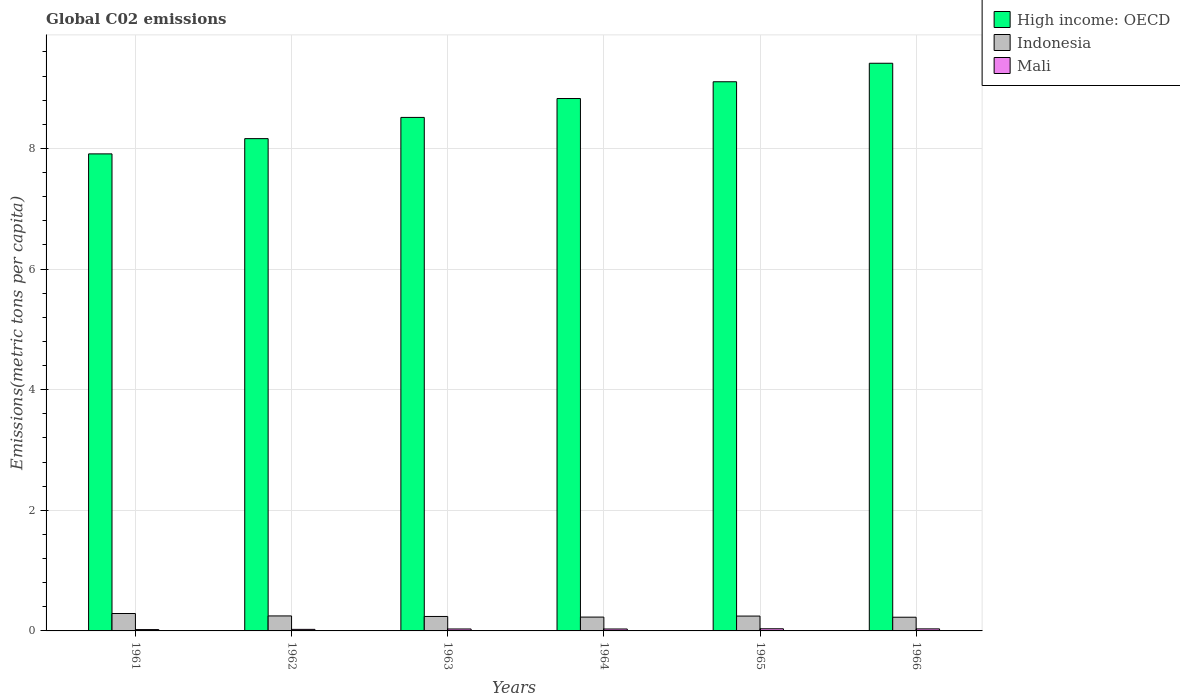How many different coloured bars are there?
Ensure brevity in your answer.  3. Are the number of bars on each tick of the X-axis equal?
Offer a very short reply. Yes. What is the label of the 2nd group of bars from the left?
Give a very brief answer. 1962. In how many cases, is the number of bars for a given year not equal to the number of legend labels?
Ensure brevity in your answer.  0. What is the amount of CO2 emitted in in High income: OECD in 1962?
Your answer should be compact. 8.16. Across all years, what is the maximum amount of CO2 emitted in in High income: OECD?
Your answer should be compact. 9.41. Across all years, what is the minimum amount of CO2 emitted in in High income: OECD?
Your response must be concise. 7.91. In which year was the amount of CO2 emitted in in High income: OECD maximum?
Offer a terse response. 1966. In which year was the amount of CO2 emitted in in Mali minimum?
Keep it short and to the point. 1961. What is the total amount of CO2 emitted in in Mali in the graph?
Ensure brevity in your answer.  0.18. What is the difference between the amount of CO2 emitted in in High income: OECD in 1962 and that in 1963?
Your answer should be very brief. -0.35. What is the difference between the amount of CO2 emitted in in Mali in 1962 and the amount of CO2 emitted in in Indonesia in 1961?
Offer a terse response. -0.26. What is the average amount of CO2 emitted in in Indonesia per year?
Give a very brief answer. 0.25. In the year 1962, what is the difference between the amount of CO2 emitted in in High income: OECD and amount of CO2 emitted in in Indonesia?
Ensure brevity in your answer.  7.91. In how many years, is the amount of CO2 emitted in in High income: OECD greater than 6.8 metric tons per capita?
Your response must be concise. 6. What is the ratio of the amount of CO2 emitted in in Mali in 1963 to that in 1965?
Provide a succinct answer. 0.91. Is the amount of CO2 emitted in in Mali in 1964 less than that in 1965?
Ensure brevity in your answer.  Yes. Is the difference between the amount of CO2 emitted in in High income: OECD in 1963 and 1966 greater than the difference between the amount of CO2 emitted in in Indonesia in 1963 and 1966?
Your answer should be very brief. No. What is the difference between the highest and the second highest amount of CO2 emitted in in High income: OECD?
Your answer should be very brief. 0.31. What is the difference between the highest and the lowest amount of CO2 emitted in in Indonesia?
Give a very brief answer. 0.06. In how many years, is the amount of CO2 emitted in in Mali greater than the average amount of CO2 emitted in in Mali taken over all years?
Make the answer very short. 4. What does the 3rd bar from the left in 1962 represents?
Your response must be concise. Mali. What does the 2nd bar from the right in 1966 represents?
Offer a very short reply. Indonesia. Is it the case that in every year, the sum of the amount of CO2 emitted in in High income: OECD and amount of CO2 emitted in in Mali is greater than the amount of CO2 emitted in in Indonesia?
Keep it short and to the point. Yes. How many bars are there?
Offer a very short reply. 18. Are all the bars in the graph horizontal?
Provide a succinct answer. No. Are the values on the major ticks of Y-axis written in scientific E-notation?
Make the answer very short. No. Does the graph contain grids?
Make the answer very short. Yes. How are the legend labels stacked?
Give a very brief answer. Vertical. What is the title of the graph?
Provide a succinct answer. Global C02 emissions. What is the label or title of the Y-axis?
Your response must be concise. Emissions(metric tons per capita). What is the Emissions(metric tons per capita) of High income: OECD in 1961?
Your answer should be compact. 7.91. What is the Emissions(metric tons per capita) in Indonesia in 1961?
Give a very brief answer. 0.29. What is the Emissions(metric tons per capita) of Mali in 1961?
Your answer should be compact. 0.02. What is the Emissions(metric tons per capita) of High income: OECD in 1962?
Offer a terse response. 8.16. What is the Emissions(metric tons per capita) in Indonesia in 1962?
Ensure brevity in your answer.  0.25. What is the Emissions(metric tons per capita) in Mali in 1962?
Keep it short and to the point. 0.03. What is the Emissions(metric tons per capita) in High income: OECD in 1963?
Ensure brevity in your answer.  8.51. What is the Emissions(metric tons per capita) of Indonesia in 1963?
Your answer should be compact. 0.24. What is the Emissions(metric tons per capita) of Mali in 1963?
Offer a terse response. 0.03. What is the Emissions(metric tons per capita) of High income: OECD in 1964?
Your answer should be compact. 8.83. What is the Emissions(metric tons per capita) of Indonesia in 1964?
Provide a succinct answer. 0.23. What is the Emissions(metric tons per capita) of Mali in 1964?
Your response must be concise. 0.03. What is the Emissions(metric tons per capita) of High income: OECD in 1965?
Your answer should be very brief. 9.11. What is the Emissions(metric tons per capita) in Indonesia in 1965?
Your response must be concise. 0.25. What is the Emissions(metric tons per capita) of Mali in 1965?
Provide a short and direct response. 0.04. What is the Emissions(metric tons per capita) in High income: OECD in 1966?
Offer a very short reply. 9.41. What is the Emissions(metric tons per capita) in Indonesia in 1966?
Offer a very short reply. 0.23. What is the Emissions(metric tons per capita) of Mali in 1966?
Your response must be concise. 0.03. Across all years, what is the maximum Emissions(metric tons per capita) of High income: OECD?
Your answer should be very brief. 9.41. Across all years, what is the maximum Emissions(metric tons per capita) of Indonesia?
Your response must be concise. 0.29. Across all years, what is the maximum Emissions(metric tons per capita) in Mali?
Provide a short and direct response. 0.04. Across all years, what is the minimum Emissions(metric tons per capita) of High income: OECD?
Your response must be concise. 7.91. Across all years, what is the minimum Emissions(metric tons per capita) in Indonesia?
Make the answer very short. 0.23. Across all years, what is the minimum Emissions(metric tons per capita) in Mali?
Provide a short and direct response. 0.02. What is the total Emissions(metric tons per capita) in High income: OECD in the graph?
Your answer should be very brief. 51.93. What is the total Emissions(metric tons per capita) in Indonesia in the graph?
Make the answer very short. 1.48. What is the total Emissions(metric tons per capita) in Mali in the graph?
Provide a succinct answer. 0.18. What is the difference between the Emissions(metric tons per capita) in High income: OECD in 1961 and that in 1962?
Your response must be concise. -0.25. What is the difference between the Emissions(metric tons per capita) of Indonesia in 1961 and that in 1962?
Your response must be concise. 0.04. What is the difference between the Emissions(metric tons per capita) in Mali in 1961 and that in 1962?
Keep it short and to the point. -0. What is the difference between the Emissions(metric tons per capita) in High income: OECD in 1961 and that in 1963?
Offer a very short reply. -0.6. What is the difference between the Emissions(metric tons per capita) in Indonesia in 1961 and that in 1963?
Your answer should be very brief. 0.05. What is the difference between the Emissions(metric tons per capita) in Mali in 1961 and that in 1963?
Your answer should be very brief. -0.01. What is the difference between the Emissions(metric tons per capita) of High income: OECD in 1961 and that in 1964?
Your answer should be compact. -0.92. What is the difference between the Emissions(metric tons per capita) of Indonesia in 1961 and that in 1964?
Your answer should be very brief. 0.06. What is the difference between the Emissions(metric tons per capita) of Mali in 1961 and that in 1964?
Ensure brevity in your answer.  -0.01. What is the difference between the Emissions(metric tons per capita) of High income: OECD in 1961 and that in 1965?
Make the answer very short. -1.2. What is the difference between the Emissions(metric tons per capita) of Indonesia in 1961 and that in 1965?
Provide a succinct answer. 0.04. What is the difference between the Emissions(metric tons per capita) in Mali in 1961 and that in 1965?
Give a very brief answer. -0.01. What is the difference between the Emissions(metric tons per capita) in High income: OECD in 1961 and that in 1966?
Give a very brief answer. -1.5. What is the difference between the Emissions(metric tons per capita) in Indonesia in 1961 and that in 1966?
Your answer should be compact. 0.06. What is the difference between the Emissions(metric tons per capita) in Mali in 1961 and that in 1966?
Provide a succinct answer. -0.01. What is the difference between the Emissions(metric tons per capita) in High income: OECD in 1962 and that in 1963?
Offer a terse response. -0.35. What is the difference between the Emissions(metric tons per capita) in Indonesia in 1962 and that in 1963?
Your answer should be compact. 0.01. What is the difference between the Emissions(metric tons per capita) of Mali in 1962 and that in 1963?
Keep it short and to the point. -0.01. What is the difference between the Emissions(metric tons per capita) of High income: OECD in 1962 and that in 1964?
Provide a short and direct response. -0.66. What is the difference between the Emissions(metric tons per capita) in Indonesia in 1962 and that in 1964?
Ensure brevity in your answer.  0.02. What is the difference between the Emissions(metric tons per capita) of Mali in 1962 and that in 1964?
Ensure brevity in your answer.  -0.01. What is the difference between the Emissions(metric tons per capita) of High income: OECD in 1962 and that in 1965?
Ensure brevity in your answer.  -0.94. What is the difference between the Emissions(metric tons per capita) in Indonesia in 1962 and that in 1965?
Your response must be concise. 0. What is the difference between the Emissions(metric tons per capita) of Mali in 1962 and that in 1965?
Your answer should be very brief. -0.01. What is the difference between the Emissions(metric tons per capita) of High income: OECD in 1962 and that in 1966?
Provide a succinct answer. -1.25. What is the difference between the Emissions(metric tons per capita) in Indonesia in 1962 and that in 1966?
Offer a very short reply. 0.02. What is the difference between the Emissions(metric tons per capita) in Mali in 1962 and that in 1966?
Offer a terse response. -0.01. What is the difference between the Emissions(metric tons per capita) in High income: OECD in 1963 and that in 1964?
Provide a succinct answer. -0.31. What is the difference between the Emissions(metric tons per capita) of Indonesia in 1963 and that in 1964?
Provide a short and direct response. 0.01. What is the difference between the Emissions(metric tons per capita) of Mali in 1963 and that in 1964?
Offer a terse response. 0. What is the difference between the Emissions(metric tons per capita) of High income: OECD in 1963 and that in 1965?
Your answer should be compact. -0.59. What is the difference between the Emissions(metric tons per capita) of Indonesia in 1963 and that in 1965?
Keep it short and to the point. -0.01. What is the difference between the Emissions(metric tons per capita) of Mali in 1963 and that in 1965?
Ensure brevity in your answer.  -0. What is the difference between the Emissions(metric tons per capita) of High income: OECD in 1963 and that in 1966?
Provide a short and direct response. -0.9. What is the difference between the Emissions(metric tons per capita) in Indonesia in 1963 and that in 1966?
Offer a terse response. 0.01. What is the difference between the Emissions(metric tons per capita) of Mali in 1963 and that in 1966?
Make the answer very short. -0. What is the difference between the Emissions(metric tons per capita) of High income: OECD in 1964 and that in 1965?
Keep it short and to the point. -0.28. What is the difference between the Emissions(metric tons per capita) in Indonesia in 1964 and that in 1965?
Offer a very short reply. -0.02. What is the difference between the Emissions(metric tons per capita) of Mali in 1964 and that in 1965?
Provide a succinct answer. -0. What is the difference between the Emissions(metric tons per capita) of High income: OECD in 1964 and that in 1966?
Keep it short and to the point. -0.58. What is the difference between the Emissions(metric tons per capita) of Indonesia in 1964 and that in 1966?
Your answer should be compact. 0. What is the difference between the Emissions(metric tons per capita) of Mali in 1964 and that in 1966?
Your answer should be very brief. -0. What is the difference between the Emissions(metric tons per capita) in High income: OECD in 1965 and that in 1966?
Keep it short and to the point. -0.31. What is the difference between the Emissions(metric tons per capita) in Indonesia in 1965 and that in 1966?
Your response must be concise. 0.02. What is the difference between the Emissions(metric tons per capita) in Mali in 1965 and that in 1966?
Your response must be concise. 0. What is the difference between the Emissions(metric tons per capita) of High income: OECD in 1961 and the Emissions(metric tons per capita) of Indonesia in 1962?
Your answer should be very brief. 7.66. What is the difference between the Emissions(metric tons per capita) of High income: OECD in 1961 and the Emissions(metric tons per capita) of Mali in 1962?
Your answer should be compact. 7.88. What is the difference between the Emissions(metric tons per capita) of Indonesia in 1961 and the Emissions(metric tons per capita) of Mali in 1962?
Your answer should be compact. 0.26. What is the difference between the Emissions(metric tons per capita) of High income: OECD in 1961 and the Emissions(metric tons per capita) of Indonesia in 1963?
Offer a terse response. 7.67. What is the difference between the Emissions(metric tons per capita) in High income: OECD in 1961 and the Emissions(metric tons per capita) in Mali in 1963?
Offer a terse response. 7.88. What is the difference between the Emissions(metric tons per capita) in Indonesia in 1961 and the Emissions(metric tons per capita) in Mali in 1963?
Ensure brevity in your answer.  0.26. What is the difference between the Emissions(metric tons per capita) of High income: OECD in 1961 and the Emissions(metric tons per capita) of Indonesia in 1964?
Offer a terse response. 7.68. What is the difference between the Emissions(metric tons per capita) of High income: OECD in 1961 and the Emissions(metric tons per capita) of Mali in 1964?
Keep it short and to the point. 7.88. What is the difference between the Emissions(metric tons per capita) of Indonesia in 1961 and the Emissions(metric tons per capita) of Mali in 1964?
Offer a terse response. 0.26. What is the difference between the Emissions(metric tons per capita) of High income: OECD in 1961 and the Emissions(metric tons per capita) of Indonesia in 1965?
Keep it short and to the point. 7.66. What is the difference between the Emissions(metric tons per capita) of High income: OECD in 1961 and the Emissions(metric tons per capita) of Mali in 1965?
Your answer should be compact. 7.87. What is the difference between the Emissions(metric tons per capita) of Indonesia in 1961 and the Emissions(metric tons per capita) of Mali in 1965?
Offer a very short reply. 0.25. What is the difference between the Emissions(metric tons per capita) of High income: OECD in 1961 and the Emissions(metric tons per capita) of Indonesia in 1966?
Your answer should be compact. 7.68. What is the difference between the Emissions(metric tons per capita) in High income: OECD in 1961 and the Emissions(metric tons per capita) in Mali in 1966?
Your response must be concise. 7.88. What is the difference between the Emissions(metric tons per capita) of Indonesia in 1961 and the Emissions(metric tons per capita) of Mali in 1966?
Ensure brevity in your answer.  0.25. What is the difference between the Emissions(metric tons per capita) in High income: OECD in 1962 and the Emissions(metric tons per capita) in Indonesia in 1963?
Offer a terse response. 7.92. What is the difference between the Emissions(metric tons per capita) of High income: OECD in 1962 and the Emissions(metric tons per capita) of Mali in 1963?
Offer a very short reply. 8.13. What is the difference between the Emissions(metric tons per capita) in Indonesia in 1962 and the Emissions(metric tons per capita) in Mali in 1963?
Offer a terse response. 0.22. What is the difference between the Emissions(metric tons per capita) of High income: OECD in 1962 and the Emissions(metric tons per capita) of Indonesia in 1964?
Give a very brief answer. 7.93. What is the difference between the Emissions(metric tons per capita) in High income: OECD in 1962 and the Emissions(metric tons per capita) in Mali in 1964?
Make the answer very short. 8.13. What is the difference between the Emissions(metric tons per capita) in Indonesia in 1962 and the Emissions(metric tons per capita) in Mali in 1964?
Your answer should be very brief. 0.22. What is the difference between the Emissions(metric tons per capita) of High income: OECD in 1962 and the Emissions(metric tons per capita) of Indonesia in 1965?
Keep it short and to the point. 7.92. What is the difference between the Emissions(metric tons per capita) of High income: OECD in 1962 and the Emissions(metric tons per capita) of Mali in 1965?
Give a very brief answer. 8.13. What is the difference between the Emissions(metric tons per capita) in Indonesia in 1962 and the Emissions(metric tons per capita) in Mali in 1965?
Provide a succinct answer. 0.21. What is the difference between the Emissions(metric tons per capita) in High income: OECD in 1962 and the Emissions(metric tons per capita) in Indonesia in 1966?
Your answer should be compact. 7.93. What is the difference between the Emissions(metric tons per capita) in High income: OECD in 1962 and the Emissions(metric tons per capita) in Mali in 1966?
Provide a succinct answer. 8.13. What is the difference between the Emissions(metric tons per capita) of Indonesia in 1962 and the Emissions(metric tons per capita) of Mali in 1966?
Offer a very short reply. 0.21. What is the difference between the Emissions(metric tons per capita) in High income: OECD in 1963 and the Emissions(metric tons per capita) in Indonesia in 1964?
Ensure brevity in your answer.  8.28. What is the difference between the Emissions(metric tons per capita) in High income: OECD in 1963 and the Emissions(metric tons per capita) in Mali in 1964?
Offer a terse response. 8.48. What is the difference between the Emissions(metric tons per capita) of Indonesia in 1963 and the Emissions(metric tons per capita) of Mali in 1964?
Provide a succinct answer. 0.21. What is the difference between the Emissions(metric tons per capita) in High income: OECD in 1963 and the Emissions(metric tons per capita) in Indonesia in 1965?
Provide a succinct answer. 8.27. What is the difference between the Emissions(metric tons per capita) of High income: OECD in 1963 and the Emissions(metric tons per capita) of Mali in 1965?
Provide a succinct answer. 8.48. What is the difference between the Emissions(metric tons per capita) in Indonesia in 1963 and the Emissions(metric tons per capita) in Mali in 1965?
Your answer should be compact. 0.2. What is the difference between the Emissions(metric tons per capita) of High income: OECD in 1963 and the Emissions(metric tons per capita) of Indonesia in 1966?
Provide a short and direct response. 8.29. What is the difference between the Emissions(metric tons per capita) of High income: OECD in 1963 and the Emissions(metric tons per capita) of Mali in 1966?
Offer a terse response. 8.48. What is the difference between the Emissions(metric tons per capita) of Indonesia in 1963 and the Emissions(metric tons per capita) of Mali in 1966?
Ensure brevity in your answer.  0.21. What is the difference between the Emissions(metric tons per capita) of High income: OECD in 1964 and the Emissions(metric tons per capita) of Indonesia in 1965?
Give a very brief answer. 8.58. What is the difference between the Emissions(metric tons per capita) of High income: OECD in 1964 and the Emissions(metric tons per capita) of Mali in 1965?
Keep it short and to the point. 8.79. What is the difference between the Emissions(metric tons per capita) in Indonesia in 1964 and the Emissions(metric tons per capita) in Mali in 1965?
Make the answer very short. 0.19. What is the difference between the Emissions(metric tons per capita) in High income: OECD in 1964 and the Emissions(metric tons per capita) in Indonesia in 1966?
Keep it short and to the point. 8.6. What is the difference between the Emissions(metric tons per capita) in High income: OECD in 1964 and the Emissions(metric tons per capita) in Mali in 1966?
Offer a terse response. 8.79. What is the difference between the Emissions(metric tons per capita) in Indonesia in 1964 and the Emissions(metric tons per capita) in Mali in 1966?
Provide a succinct answer. 0.2. What is the difference between the Emissions(metric tons per capita) of High income: OECD in 1965 and the Emissions(metric tons per capita) of Indonesia in 1966?
Provide a succinct answer. 8.88. What is the difference between the Emissions(metric tons per capita) in High income: OECD in 1965 and the Emissions(metric tons per capita) in Mali in 1966?
Offer a very short reply. 9.07. What is the difference between the Emissions(metric tons per capita) in Indonesia in 1965 and the Emissions(metric tons per capita) in Mali in 1966?
Your response must be concise. 0.21. What is the average Emissions(metric tons per capita) in High income: OECD per year?
Offer a terse response. 8.65. What is the average Emissions(metric tons per capita) in Indonesia per year?
Offer a terse response. 0.25. What is the average Emissions(metric tons per capita) of Mali per year?
Provide a short and direct response. 0.03. In the year 1961, what is the difference between the Emissions(metric tons per capita) of High income: OECD and Emissions(metric tons per capita) of Indonesia?
Ensure brevity in your answer.  7.62. In the year 1961, what is the difference between the Emissions(metric tons per capita) in High income: OECD and Emissions(metric tons per capita) in Mali?
Your answer should be very brief. 7.89. In the year 1961, what is the difference between the Emissions(metric tons per capita) in Indonesia and Emissions(metric tons per capita) in Mali?
Keep it short and to the point. 0.27. In the year 1962, what is the difference between the Emissions(metric tons per capita) of High income: OECD and Emissions(metric tons per capita) of Indonesia?
Your answer should be very brief. 7.91. In the year 1962, what is the difference between the Emissions(metric tons per capita) in High income: OECD and Emissions(metric tons per capita) in Mali?
Offer a very short reply. 8.14. In the year 1962, what is the difference between the Emissions(metric tons per capita) in Indonesia and Emissions(metric tons per capita) in Mali?
Offer a terse response. 0.22. In the year 1963, what is the difference between the Emissions(metric tons per capita) in High income: OECD and Emissions(metric tons per capita) in Indonesia?
Give a very brief answer. 8.27. In the year 1963, what is the difference between the Emissions(metric tons per capita) in High income: OECD and Emissions(metric tons per capita) in Mali?
Your answer should be compact. 8.48. In the year 1963, what is the difference between the Emissions(metric tons per capita) in Indonesia and Emissions(metric tons per capita) in Mali?
Provide a short and direct response. 0.21. In the year 1964, what is the difference between the Emissions(metric tons per capita) in High income: OECD and Emissions(metric tons per capita) in Indonesia?
Make the answer very short. 8.6. In the year 1964, what is the difference between the Emissions(metric tons per capita) in High income: OECD and Emissions(metric tons per capita) in Mali?
Ensure brevity in your answer.  8.79. In the year 1964, what is the difference between the Emissions(metric tons per capita) in Indonesia and Emissions(metric tons per capita) in Mali?
Give a very brief answer. 0.2. In the year 1965, what is the difference between the Emissions(metric tons per capita) of High income: OECD and Emissions(metric tons per capita) of Indonesia?
Make the answer very short. 8.86. In the year 1965, what is the difference between the Emissions(metric tons per capita) in High income: OECD and Emissions(metric tons per capita) in Mali?
Give a very brief answer. 9.07. In the year 1965, what is the difference between the Emissions(metric tons per capita) in Indonesia and Emissions(metric tons per capita) in Mali?
Offer a terse response. 0.21. In the year 1966, what is the difference between the Emissions(metric tons per capita) in High income: OECD and Emissions(metric tons per capita) in Indonesia?
Your answer should be very brief. 9.18. In the year 1966, what is the difference between the Emissions(metric tons per capita) of High income: OECD and Emissions(metric tons per capita) of Mali?
Offer a very short reply. 9.38. In the year 1966, what is the difference between the Emissions(metric tons per capita) of Indonesia and Emissions(metric tons per capita) of Mali?
Your answer should be very brief. 0.19. What is the ratio of the Emissions(metric tons per capita) of Indonesia in 1961 to that in 1962?
Provide a short and direct response. 1.16. What is the ratio of the Emissions(metric tons per capita) of Mali in 1961 to that in 1962?
Give a very brief answer. 0.85. What is the ratio of the Emissions(metric tons per capita) of High income: OECD in 1961 to that in 1963?
Make the answer very short. 0.93. What is the ratio of the Emissions(metric tons per capita) in Indonesia in 1961 to that in 1963?
Give a very brief answer. 1.2. What is the ratio of the Emissions(metric tons per capita) of Mali in 1961 to that in 1963?
Provide a short and direct response. 0.68. What is the ratio of the Emissions(metric tons per capita) in High income: OECD in 1961 to that in 1964?
Provide a succinct answer. 0.9. What is the ratio of the Emissions(metric tons per capita) in Indonesia in 1961 to that in 1964?
Offer a very short reply. 1.26. What is the ratio of the Emissions(metric tons per capita) of Mali in 1961 to that in 1964?
Make the answer very short. 0.69. What is the ratio of the Emissions(metric tons per capita) in High income: OECD in 1961 to that in 1965?
Ensure brevity in your answer.  0.87. What is the ratio of the Emissions(metric tons per capita) of Indonesia in 1961 to that in 1965?
Offer a terse response. 1.17. What is the ratio of the Emissions(metric tons per capita) of Mali in 1961 to that in 1965?
Your response must be concise. 0.62. What is the ratio of the Emissions(metric tons per capita) in High income: OECD in 1961 to that in 1966?
Your answer should be very brief. 0.84. What is the ratio of the Emissions(metric tons per capita) in Indonesia in 1961 to that in 1966?
Provide a short and direct response. 1.27. What is the ratio of the Emissions(metric tons per capita) of Mali in 1961 to that in 1966?
Make the answer very short. 0.65. What is the ratio of the Emissions(metric tons per capita) in High income: OECD in 1962 to that in 1963?
Offer a very short reply. 0.96. What is the ratio of the Emissions(metric tons per capita) in Indonesia in 1962 to that in 1963?
Give a very brief answer. 1.04. What is the ratio of the Emissions(metric tons per capita) in Mali in 1962 to that in 1963?
Your answer should be very brief. 0.8. What is the ratio of the Emissions(metric tons per capita) in High income: OECD in 1962 to that in 1964?
Ensure brevity in your answer.  0.92. What is the ratio of the Emissions(metric tons per capita) of Indonesia in 1962 to that in 1964?
Your response must be concise. 1.08. What is the ratio of the Emissions(metric tons per capita) in Mali in 1962 to that in 1964?
Your answer should be compact. 0.81. What is the ratio of the Emissions(metric tons per capita) of High income: OECD in 1962 to that in 1965?
Provide a short and direct response. 0.9. What is the ratio of the Emissions(metric tons per capita) of Indonesia in 1962 to that in 1965?
Give a very brief answer. 1.01. What is the ratio of the Emissions(metric tons per capita) of Mali in 1962 to that in 1965?
Keep it short and to the point. 0.73. What is the ratio of the Emissions(metric tons per capita) in High income: OECD in 1962 to that in 1966?
Your response must be concise. 0.87. What is the ratio of the Emissions(metric tons per capita) of Indonesia in 1962 to that in 1966?
Your response must be concise. 1.09. What is the ratio of the Emissions(metric tons per capita) of Mali in 1962 to that in 1966?
Your answer should be very brief. 0.77. What is the ratio of the Emissions(metric tons per capita) of High income: OECD in 1963 to that in 1964?
Make the answer very short. 0.96. What is the ratio of the Emissions(metric tons per capita) of Indonesia in 1963 to that in 1964?
Make the answer very short. 1.04. What is the ratio of the Emissions(metric tons per capita) in Mali in 1963 to that in 1964?
Your answer should be compact. 1.01. What is the ratio of the Emissions(metric tons per capita) of High income: OECD in 1963 to that in 1965?
Give a very brief answer. 0.94. What is the ratio of the Emissions(metric tons per capita) in Indonesia in 1963 to that in 1965?
Keep it short and to the point. 0.97. What is the ratio of the Emissions(metric tons per capita) of Mali in 1963 to that in 1965?
Your answer should be very brief. 0.91. What is the ratio of the Emissions(metric tons per capita) in High income: OECD in 1963 to that in 1966?
Make the answer very short. 0.9. What is the ratio of the Emissions(metric tons per capita) in Indonesia in 1963 to that in 1966?
Make the answer very short. 1.06. What is the ratio of the Emissions(metric tons per capita) in Mali in 1963 to that in 1966?
Give a very brief answer. 0.96. What is the ratio of the Emissions(metric tons per capita) of High income: OECD in 1964 to that in 1965?
Ensure brevity in your answer.  0.97. What is the ratio of the Emissions(metric tons per capita) in Indonesia in 1964 to that in 1965?
Make the answer very short. 0.93. What is the ratio of the Emissions(metric tons per capita) in Mali in 1964 to that in 1965?
Ensure brevity in your answer.  0.9. What is the ratio of the Emissions(metric tons per capita) in High income: OECD in 1964 to that in 1966?
Provide a short and direct response. 0.94. What is the ratio of the Emissions(metric tons per capita) of Indonesia in 1964 to that in 1966?
Your answer should be very brief. 1.01. What is the ratio of the Emissions(metric tons per capita) in Mali in 1964 to that in 1966?
Your answer should be compact. 0.95. What is the ratio of the Emissions(metric tons per capita) in High income: OECD in 1965 to that in 1966?
Your answer should be very brief. 0.97. What is the ratio of the Emissions(metric tons per capita) in Indonesia in 1965 to that in 1966?
Ensure brevity in your answer.  1.08. What is the ratio of the Emissions(metric tons per capita) in Mali in 1965 to that in 1966?
Your answer should be compact. 1.05. What is the difference between the highest and the second highest Emissions(metric tons per capita) in High income: OECD?
Keep it short and to the point. 0.31. What is the difference between the highest and the second highest Emissions(metric tons per capita) of Indonesia?
Ensure brevity in your answer.  0.04. What is the difference between the highest and the second highest Emissions(metric tons per capita) of Mali?
Provide a short and direct response. 0. What is the difference between the highest and the lowest Emissions(metric tons per capita) of High income: OECD?
Your response must be concise. 1.5. What is the difference between the highest and the lowest Emissions(metric tons per capita) of Indonesia?
Your answer should be very brief. 0.06. What is the difference between the highest and the lowest Emissions(metric tons per capita) in Mali?
Offer a very short reply. 0.01. 